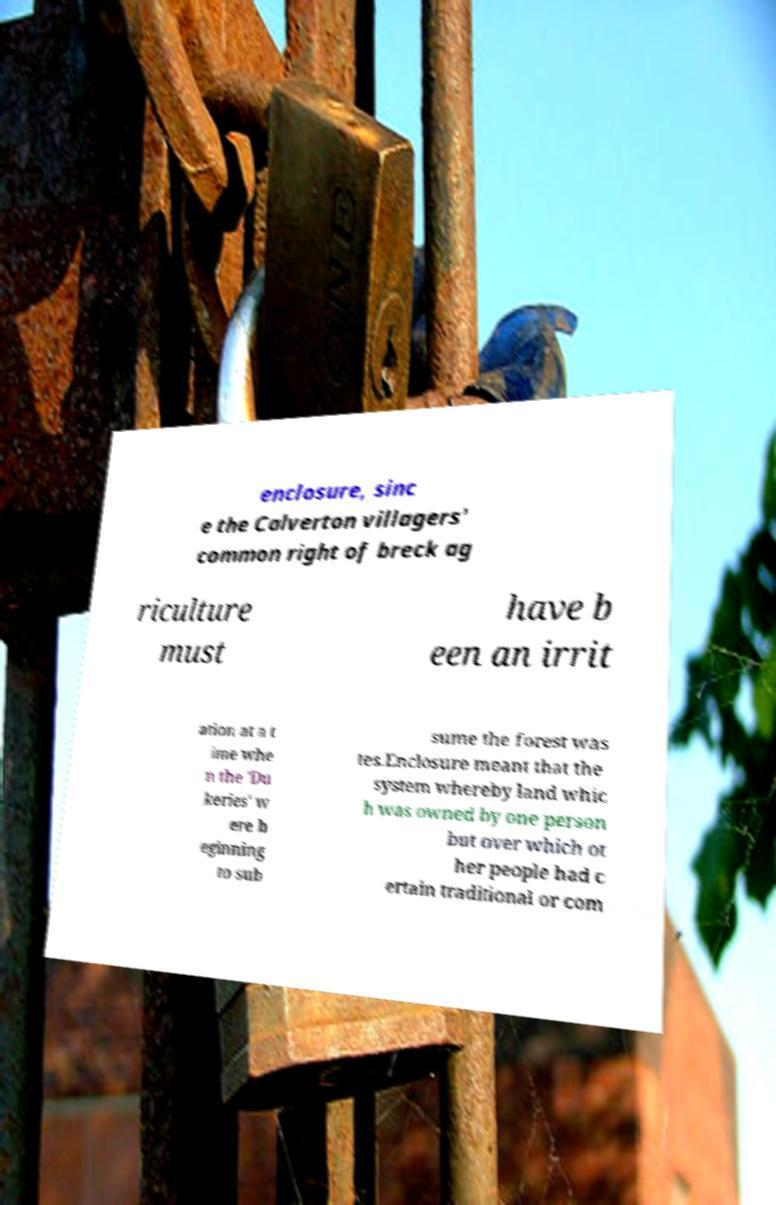Can you accurately transcribe the text from the provided image for me? enclosure, sinc e the Calverton villagers' common right of breck ag riculture must have b een an irrit ation at a t ime whe n the 'Du keries' w ere b eginning to sub sume the forest was tes.Enclosure meant that the system whereby land whic h was owned by one person but over which ot her people had c ertain traditional or com 